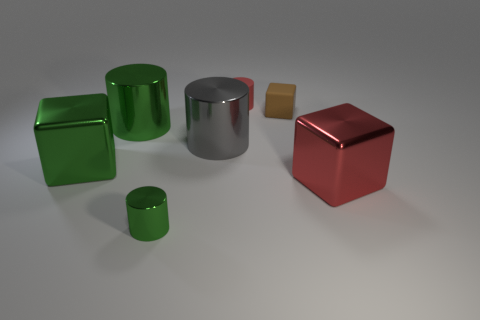There is a red thing that is the same size as the brown thing; what is its material?
Ensure brevity in your answer.  Rubber. What color is the other metallic thing that is the same shape as the large red thing?
Keep it short and to the point. Green. The green thing in front of the big shiny cube that is on the right side of the big metallic cylinder left of the small green metallic object is what shape?
Give a very brief answer. Cylinder. Is the red metal thing the same shape as the brown matte object?
Offer a very short reply. Yes. There is a small brown matte object to the right of the block that is to the left of the big green cylinder; what shape is it?
Offer a very short reply. Cube. Are any cyan rubber blocks visible?
Provide a short and direct response. No. How many large red shiny blocks are in front of the block that is on the left side of the green shiny cylinder that is behind the gray metallic cylinder?
Your response must be concise. 1. Is the shape of the brown object the same as the green metal thing that is in front of the large green shiny block?
Your answer should be compact. No. Are there more objects than tiny metal spheres?
Offer a terse response. Yes. Is there anything else that is the same size as the gray object?
Provide a succinct answer. Yes. 